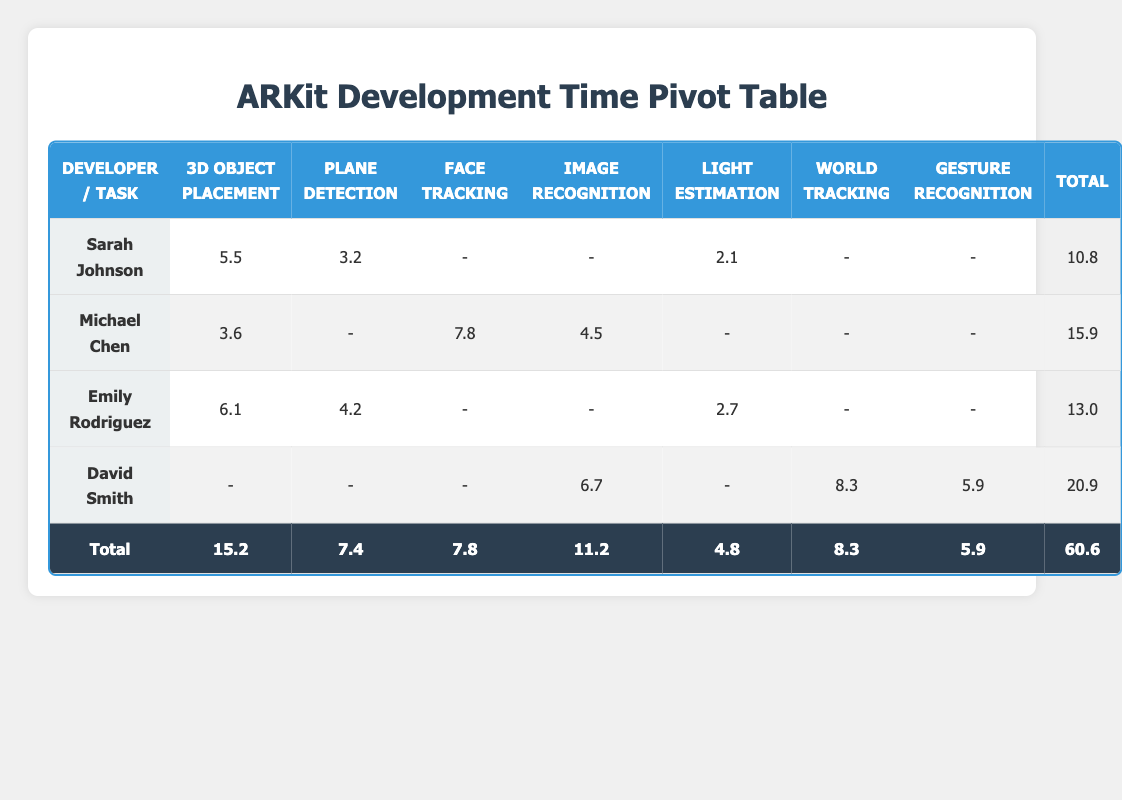What is the total time spent by Sarah Johnson on AR development tasks? To find the total time spent by Sarah Johnson, we look at the row corresponding to her name. The time spent is 5.5 for 3D Object Placement, 3.2 for Plane Detection, and 2.1 for Light Estimation. We sum these values: 5.5 + 3.2 + 2.1 = 10.8.
Answer: 10.8 Which developer spent the most time on AR development tasks? Checking the total column, we find the totals for each developer: Sarah Johnson has 10.8, Michael Chen has 15.9, Emily Rodriguez has 13.0, and David Smith has 20.9. David Smith has the highest total.
Answer: David Smith What is the average time spent on 3D Object Placement across all developers? The time spent on 3D Object Placement is 5.5 (Sarah Johnson), 3.6 (Michael Chen), and 6.1 (Emily Rodriguez). The sum of these times is 5.5 + 3.6 + 6.1 = 15.2. Dividing by the number of developers (3), we get 15.2 / 3 = 5.07.
Answer: 5.07 Did Emily Rodriguez work on Face Tracking? Looking at the table, Emily Rodriguez’s tasks are 3D Object Placement, Plane Detection, and Light Estimation. There is no entry for Face Tracking.
Answer: No What is the difference in total hours spent between Michael Chen and David Smith? Michael Chen’s total is 15.9, and David Smith’s total is 20.9. The difference is calculated by subtracting Michael’s total from David’s: 20.9 - 15.9 = 5.0.
Answer: 5.0 How much time did David Smith spend on Gesture Recognition? Looking at David Smith’s row, the time spent on Gesture Recognition is 5.9, which is found directly in the corresponding cell.
Answer: 5.9 What percentage of total time spent was on Image Recognition? First, we sum the total time spent: 60.6. The time spent on Image Recognition is 11.2. The percentage is calculated as (11.2 / 60.6) * 100, which yields approximately 18.45%.
Answer: 18.45% Which task had the highest total time spent across all developers? We need to look at the total time spent for each task: 3D Object Placement (15.2), Plane Detection (7.4), Face Tracking (7.8), Image Recognition (11.2), Light Estimation (4.8), World Tracking (8.3), and Gesture Recognition (5.9). The highest total is for 3D Object Placement.
Answer: 3D Object Placement 